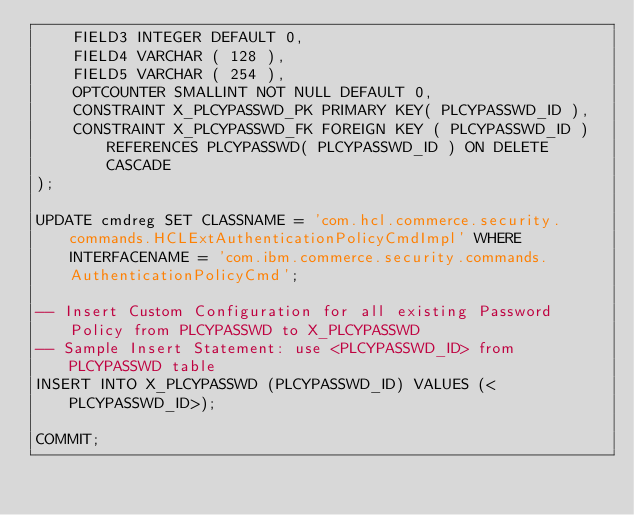Convert code to text. <code><loc_0><loc_0><loc_500><loc_500><_SQL_>	FIELD3 INTEGER DEFAULT 0,
	FIELD4 VARCHAR ( 128 ),
	FIELD5 VARCHAR ( 254 ),
	OPTCOUNTER SMALLINT NOT NULL DEFAULT 0,
	CONSTRAINT X_PLCYPASSWD_PK PRIMARY KEY( PLCYPASSWD_ID ),
	CONSTRAINT X_PLCYPASSWD_FK FOREIGN KEY ( PLCYPASSWD_ID ) REFERENCES PLCYPASSWD( PLCYPASSWD_ID ) ON DELETE CASCADE 
);

UPDATE cmdreg SET CLASSNAME = 'com.hcl.commerce.security.commands.HCLExtAuthenticationPolicyCmdImpl' WHERE INTERFACENAME = 'com.ibm.commerce.security.commands.AuthenticationPolicyCmd';

-- Insert Custom Configuration for all existing Password Policy from PLCYPASSWD to X_PLCYPASSWD 
-- Sample Insert Statement: use <PLCYPASSWD_ID> from PLCYPASSWD table
INSERT INTO X_PLCYPASSWD (PLCYPASSWD_ID) VALUES (<PLCYPASSWD_ID>);

COMMIT;
</code> 